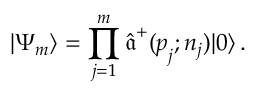Convert formula to latex. <formula><loc_0><loc_0><loc_500><loc_500>| \Psi _ { m } \rangle = \prod _ { j = 1 } ^ { m } \hat { \mathfrak a } ^ { + } ( p _ { j } ; n _ { j } ) | 0 \rangle \, .</formula> 